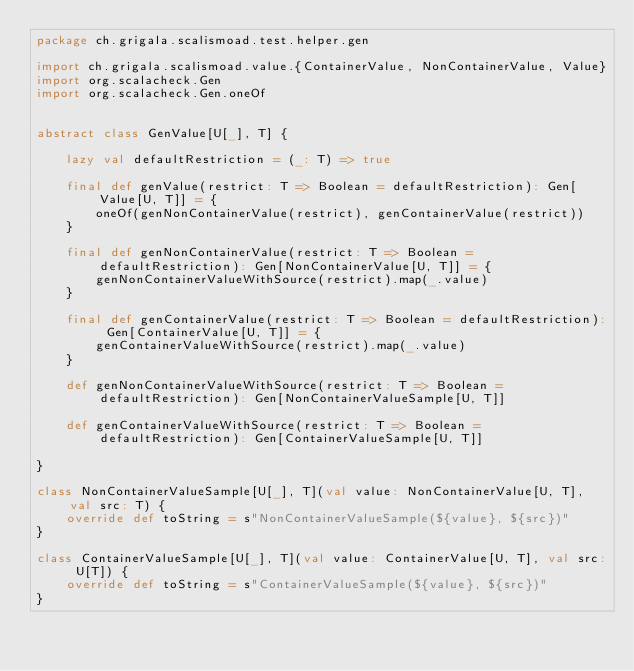<code> <loc_0><loc_0><loc_500><loc_500><_Scala_>package ch.grigala.scalismoad.test.helper.gen

import ch.grigala.scalismoad.value.{ContainerValue, NonContainerValue, Value}
import org.scalacheck.Gen
import org.scalacheck.Gen.oneOf


abstract class GenValue[U[_], T] {

    lazy val defaultRestriction = (_: T) => true

    final def genValue(restrict: T => Boolean = defaultRestriction): Gen[Value[U, T]] = {
        oneOf(genNonContainerValue(restrict), genContainerValue(restrict))
    }

    final def genNonContainerValue(restrict: T => Boolean = defaultRestriction): Gen[NonContainerValue[U, T]] = {
        genNonContainerValueWithSource(restrict).map(_.value)
    }

    final def genContainerValue(restrict: T => Boolean = defaultRestriction): Gen[ContainerValue[U, T]] = {
        genContainerValueWithSource(restrict).map(_.value)
    }

    def genNonContainerValueWithSource(restrict: T => Boolean = defaultRestriction): Gen[NonContainerValueSample[U, T]]

    def genContainerValueWithSource(restrict: T => Boolean = defaultRestriction): Gen[ContainerValueSample[U, T]]

}

class NonContainerValueSample[U[_], T](val value: NonContainerValue[U, T], val src: T) {
    override def toString = s"NonContainerValueSample(${value}, ${src})"
}

class ContainerValueSample[U[_], T](val value: ContainerValue[U, T], val src: U[T]) {
    override def toString = s"ContainerValueSample(${value}, ${src})"
}
</code> 